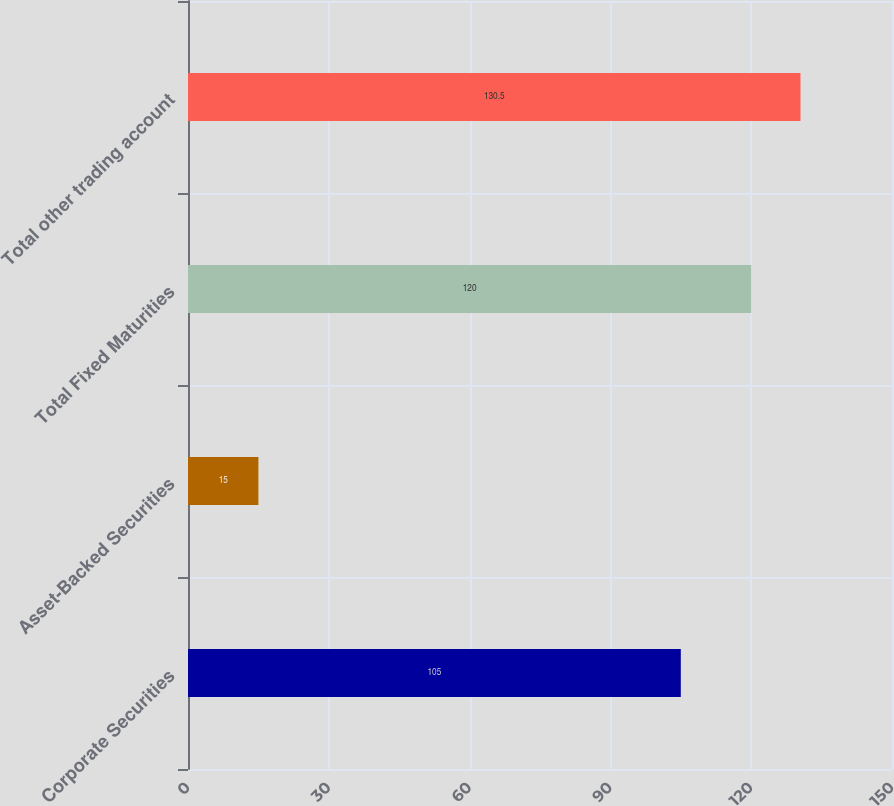Convert chart to OTSL. <chart><loc_0><loc_0><loc_500><loc_500><bar_chart><fcel>Corporate Securities<fcel>Asset-Backed Securities<fcel>Total Fixed Maturities<fcel>Total other trading account<nl><fcel>105<fcel>15<fcel>120<fcel>130.5<nl></chart> 